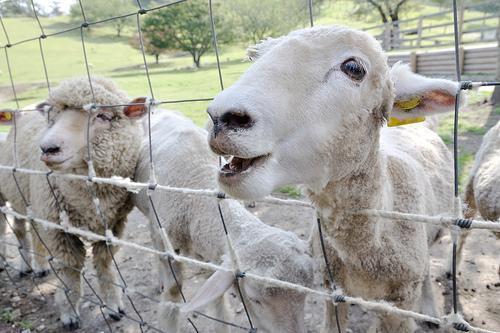How many sheep are sticking their head through the fence?
Give a very brief answer. 2. 